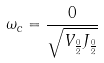<formula> <loc_0><loc_0><loc_500><loc_500>\omega _ { c } = \frac { 0 } { \sqrt { V _ { \frac { 0 } { 2 } } J _ { \frac { 0 } { 2 } } } }</formula> 